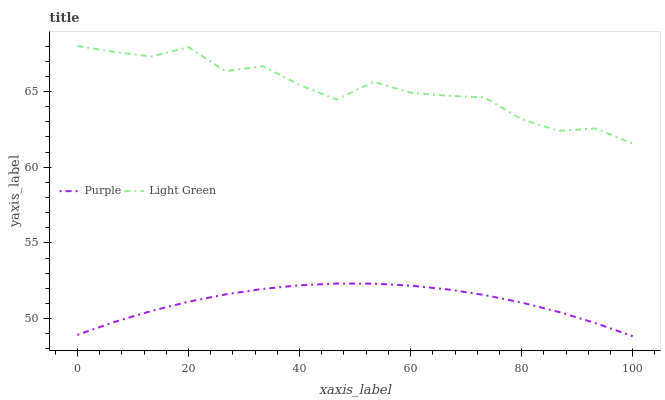Does Purple have the minimum area under the curve?
Answer yes or no. Yes. Does Light Green have the maximum area under the curve?
Answer yes or no. Yes. Does Light Green have the minimum area under the curve?
Answer yes or no. No. Is Purple the smoothest?
Answer yes or no. Yes. Is Light Green the roughest?
Answer yes or no. Yes. Is Light Green the smoothest?
Answer yes or no. No. Does Purple have the lowest value?
Answer yes or no. Yes. Does Light Green have the lowest value?
Answer yes or no. No. Does Light Green have the highest value?
Answer yes or no. Yes. Is Purple less than Light Green?
Answer yes or no. Yes. Is Light Green greater than Purple?
Answer yes or no. Yes. Does Purple intersect Light Green?
Answer yes or no. No. 